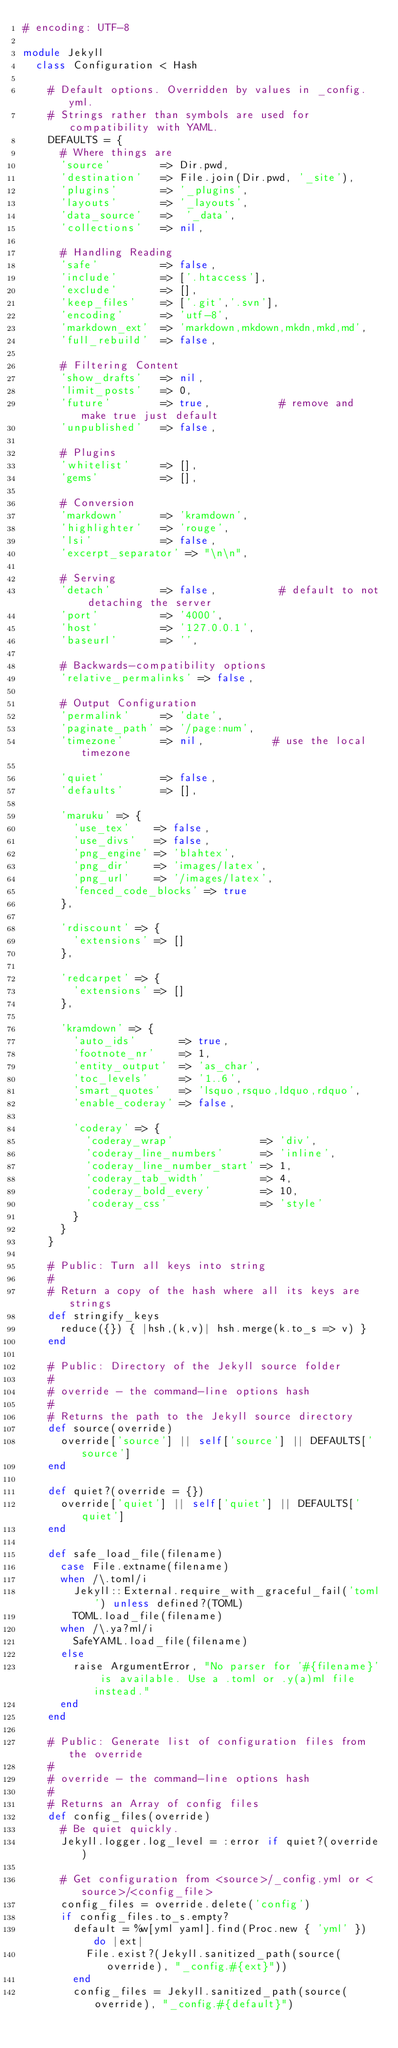Convert code to text. <code><loc_0><loc_0><loc_500><loc_500><_Ruby_># encoding: UTF-8

module Jekyll
  class Configuration < Hash

    # Default options. Overridden by values in _config.yml.
    # Strings rather than symbols are used for compatibility with YAML.
    DEFAULTS = {
      # Where things are
      'source'        => Dir.pwd,
      'destination'   => File.join(Dir.pwd, '_site'),
      'plugins'       => '_plugins',
      'layouts'       => '_layouts',
      'data_source'   =>  '_data',
      'collections'   => nil,

      # Handling Reading
      'safe'          => false,
      'include'       => ['.htaccess'],
      'exclude'       => [],
      'keep_files'    => ['.git','.svn'],
      'encoding'      => 'utf-8',
      'markdown_ext'  => 'markdown,mkdown,mkdn,mkd,md',
      'full_rebuild'  => false,

      # Filtering Content
      'show_drafts'   => nil,
      'limit_posts'   => 0,
      'future'        => true,           # remove and make true just default
      'unpublished'   => false,

      # Plugins
      'whitelist'     => [],
      'gems'          => [],

      # Conversion
      'markdown'      => 'kramdown',
      'highlighter'   => 'rouge',
      'lsi'           => false,
      'excerpt_separator' => "\n\n",

      # Serving
      'detach'        => false,          # default to not detaching the server
      'port'          => '4000',
      'host'          => '127.0.0.1',
      'baseurl'       => '',

      # Backwards-compatibility options
      'relative_permalinks' => false,

      # Output Configuration
      'permalink'     => 'date',
      'paginate_path' => '/page:num',
      'timezone'      => nil,           # use the local timezone

      'quiet'         => false,
      'defaults'      => [],

      'maruku' => {
        'use_tex'    => false,
        'use_divs'   => false,
        'png_engine' => 'blahtex',
        'png_dir'    => 'images/latex',
        'png_url'    => '/images/latex',
        'fenced_code_blocks' => true
      },

      'rdiscount' => {
        'extensions' => []
      },

      'redcarpet' => {
        'extensions' => []
      },

      'kramdown' => {
        'auto_ids'       => true,
        'footnote_nr'    => 1,
        'entity_output'  => 'as_char',
        'toc_levels'     => '1..6',
        'smart_quotes'   => 'lsquo,rsquo,ldquo,rdquo',
        'enable_coderay' => false,

        'coderay' => {
          'coderay_wrap'              => 'div',
          'coderay_line_numbers'      => 'inline',
          'coderay_line_number_start' => 1,
          'coderay_tab_width'         => 4,
          'coderay_bold_every'        => 10,
          'coderay_css'               => 'style'
        }
      }
    }

    # Public: Turn all keys into string
    #
    # Return a copy of the hash where all its keys are strings
    def stringify_keys
      reduce({}) { |hsh,(k,v)| hsh.merge(k.to_s => v) }
    end

    # Public: Directory of the Jekyll source folder
    #
    # override - the command-line options hash
    #
    # Returns the path to the Jekyll source directory
    def source(override)
      override['source'] || self['source'] || DEFAULTS['source']
    end

    def quiet?(override = {})
      override['quiet'] || self['quiet'] || DEFAULTS['quiet']
    end

    def safe_load_file(filename)
      case File.extname(filename)
      when /\.toml/i
        Jekyll::External.require_with_graceful_fail('toml') unless defined?(TOML)
        TOML.load_file(filename)
      when /\.ya?ml/i
        SafeYAML.load_file(filename)
      else
        raise ArgumentError, "No parser for '#{filename}' is available. Use a .toml or .y(a)ml file instead."
      end
    end

    # Public: Generate list of configuration files from the override
    #
    # override - the command-line options hash
    #
    # Returns an Array of config files
    def config_files(override)
      # Be quiet quickly.
      Jekyll.logger.log_level = :error if quiet?(override)

      # Get configuration from <source>/_config.yml or <source>/<config_file>
      config_files = override.delete('config')
      if config_files.to_s.empty?
        default = %w[yml yaml].find(Proc.new { 'yml' }) do |ext|
          File.exist?(Jekyll.sanitized_path(source(override), "_config.#{ext}"))
        end
        config_files = Jekyll.sanitized_path(source(override), "_config.#{default}")</code> 